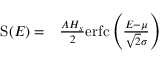Convert formula to latex. <formula><loc_0><loc_0><loc_500><loc_500>\begin{array} { r l } { S ( E ) = } & \frac { A H _ { s } } { 2 } e r f c \left ( \frac { E - \mu } { \sqrt { 2 } \sigma } \right ) } \end{array}</formula> 